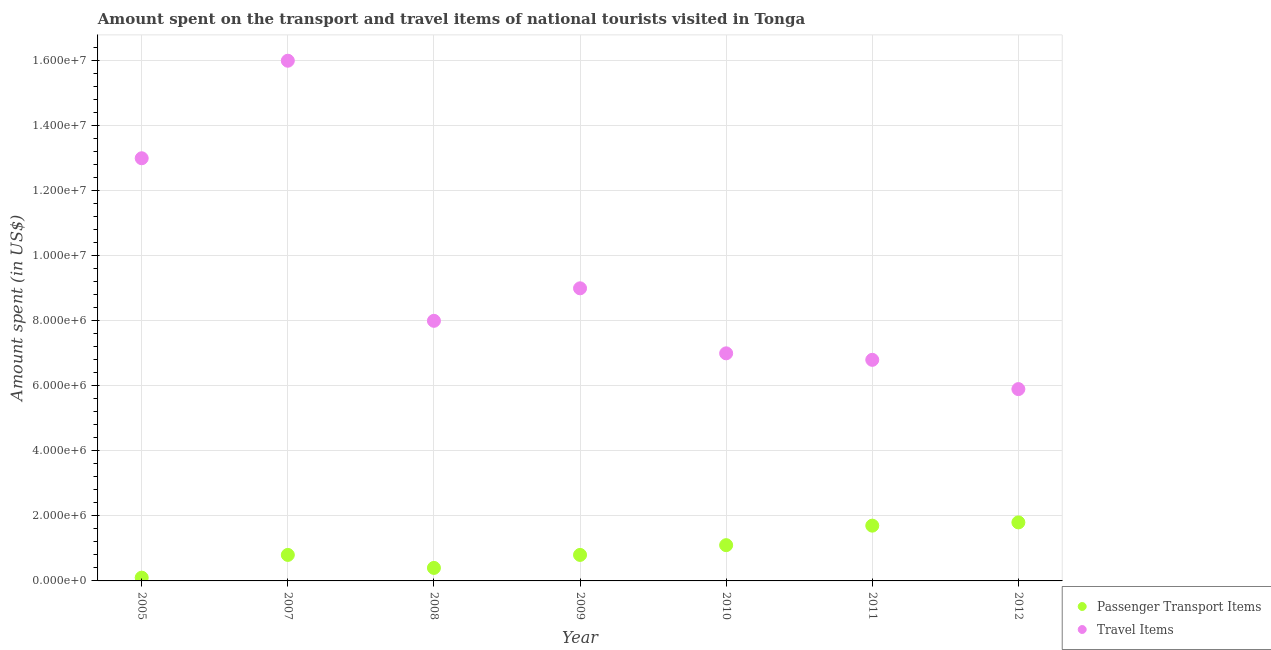How many different coloured dotlines are there?
Provide a short and direct response. 2. What is the amount spent on passenger transport items in 2012?
Your answer should be very brief. 1.80e+06. Across all years, what is the maximum amount spent on passenger transport items?
Your answer should be compact. 1.80e+06. Across all years, what is the minimum amount spent on passenger transport items?
Keep it short and to the point. 1.00e+05. In which year was the amount spent on passenger transport items maximum?
Keep it short and to the point. 2012. What is the total amount spent in travel items in the graph?
Offer a very short reply. 6.57e+07. What is the difference between the amount spent in travel items in 2010 and that in 2011?
Make the answer very short. 2.00e+05. What is the difference between the amount spent in travel items in 2011 and the amount spent on passenger transport items in 2010?
Offer a terse response. 5.70e+06. What is the average amount spent on passenger transport items per year?
Provide a succinct answer. 9.57e+05. In the year 2007, what is the difference between the amount spent in travel items and amount spent on passenger transport items?
Provide a short and direct response. 1.52e+07. In how many years, is the amount spent in travel items greater than 14800000 US$?
Offer a terse response. 1. What is the ratio of the amount spent on passenger transport items in 2009 to that in 2011?
Offer a terse response. 0.47. Is the difference between the amount spent in travel items in 2011 and 2012 greater than the difference between the amount spent on passenger transport items in 2011 and 2012?
Make the answer very short. Yes. What is the difference between the highest and the second highest amount spent in travel items?
Your answer should be compact. 3.00e+06. What is the difference between the highest and the lowest amount spent on passenger transport items?
Provide a short and direct response. 1.70e+06. In how many years, is the amount spent in travel items greater than the average amount spent in travel items taken over all years?
Offer a terse response. 2. How many years are there in the graph?
Provide a succinct answer. 7. What is the difference between two consecutive major ticks on the Y-axis?
Keep it short and to the point. 2.00e+06. Where does the legend appear in the graph?
Offer a terse response. Bottom right. How many legend labels are there?
Ensure brevity in your answer.  2. What is the title of the graph?
Your answer should be compact. Amount spent on the transport and travel items of national tourists visited in Tonga. Does "Researchers" appear as one of the legend labels in the graph?
Provide a succinct answer. No. What is the label or title of the X-axis?
Offer a very short reply. Year. What is the label or title of the Y-axis?
Provide a short and direct response. Amount spent (in US$). What is the Amount spent (in US$) of Passenger Transport Items in 2005?
Provide a succinct answer. 1.00e+05. What is the Amount spent (in US$) in Travel Items in 2005?
Your answer should be compact. 1.30e+07. What is the Amount spent (in US$) of Passenger Transport Items in 2007?
Offer a very short reply. 8.00e+05. What is the Amount spent (in US$) of Travel Items in 2007?
Make the answer very short. 1.60e+07. What is the Amount spent (in US$) of Travel Items in 2009?
Make the answer very short. 9.00e+06. What is the Amount spent (in US$) of Passenger Transport Items in 2010?
Provide a short and direct response. 1.10e+06. What is the Amount spent (in US$) of Passenger Transport Items in 2011?
Offer a very short reply. 1.70e+06. What is the Amount spent (in US$) of Travel Items in 2011?
Offer a terse response. 6.80e+06. What is the Amount spent (in US$) of Passenger Transport Items in 2012?
Offer a terse response. 1.80e+06. What is the Amount spent (in US$) in Travel Items in 2012?
Your answer should be very brief. 5.90e+06. Across all years, what is the maximum Amount spent (in US$) of Passenger Transport Items?
Ensure brevity in your answer.  1.80e+06. Across all years, what is the maximum Amount spent (in US$) of Travel Items?
Your answer should be very brief. 1.60e+07. Across all years, what is the minimum Amount spent (in US$) in Travel Items?
Provide a succinct answer. 5.90e+06. What is the total Amount spent (in US$) in Passenger Transport Items in the graph?
Provide a short and direct response. 6.70e+06. What is the total Amount spent (in US$) in Travel Items in the graph?
Your answer should be compact. 6.57e+07. What is the difference between the Amount spent (in US$) of Passenger Transport Items in 2005 and that in 2007?
Your response must be concise. -7.00e+05. What is the difference between the Amount spent (in US$) in Travel Items in 2005 and that in 2007?
Your answer should be very brief. -3.00e+06. What is the difference between the Amount spent (in US$) in Passenger Transport Items in 2005 and that in 2008?
Provide a succinct answer. -3.00e+05. What is the difference between the Amount spent (in US$) of Passenger Transport Items in 2005 and that in 2009?
Give a very brief answer. -7.00e+05. What is the difference between the Amount spent (in US$) of Travel Items in 2005 and that in 2009?
Ensure brevity in your answer.  4.00e+06. What is the difference between the Amount spent (in US$) of Passenger Transport Items in 2005 and that in 2010?
Give a very brief answer. -1.00e+06. What is the difference between the Amount spent (in US$) of Passenger Transport Items in 2005 and that in 2011?
Your answer should be very brief. -1.60e+06. What is the difference between the Amount spent (in US$) of Travel Items in 2005 and that in 2011?
Provide a short and direct response. 6.20e+06. What is the difference between the Amount spent (in US$) of Passenger Transport Items in 2005 and that in 2012?
Your answer should be compact. -1.70e+06. What is the difference between the Amount spent (in US$) in Travel Items in 2005 and that in 2012?
Ensure brevity in your answer.  7.10e+06. What is the difference between the Amount spent (in US$) of Passenger Transport Items in 2007 and that in 2008?
Your answer should be very brief. 4.00e+05. What is the difference between the Amount spent (in US$) in Travel Items in 2007 and that in 2009?
Give a very brief answer. 7.00e+06. What is the difference between the Amount spent (in US$) of Passenger Transport Items in 2007 and that in 2010?
Give a very brief answer. -3.00e+05. What is the difference between the Amount spent (in US$) of Travel Items in 2007 and that in 2010?
Ensure brevity in your answer.  9.00e+06. What is the difference between the Amount spent (in US$) of Passenger Transport Items in 2007 and that in 2011?
Make the answer very short. -9.00e+05. What is the difference between the Amount spent (in US$) in Travel Items in 2007 and that in 2011?
Offer a terse response. 9.20e+06. What is the difference between the Amount spent (in US$) in Passenger Transport Items in 2007 and that in 2012?
Your response must be concise. -1.00e+06. What is the difference between the Amount spent (in US$) in Travel Items in 2007 and that in 2012?
Your answer should be compact. 1.01e+07. What is the difference between the Amount spent (in US$) in Passenger Transport Items in 2008 and that in 2009?
Keep it short and to the point. -4.00e+05. What is the difference between the Amount spent (in US$) of Passenger Transport Items in 2008 and that in 2010?
Your answer should be very brief. -7.00e+05. What is the difference between the Amount spent (in US$) in Passenger Transport Items in 2008 and that in 2011?
Provide a short and direct response. -1.30e+06. What is the difference between the Amount spent (in US$) of Travel Items in 2008 and that in 2011?
Provide a succinct answer. 1.20e+06. What is the difference between the Amount spent (in US$) in Passenger Transport Items in 2008 and that in 2012?
Keep it short and to the point. -1.40e+06. What is the difference between the Amount spent (in US$) of Travel Items in 2008 and that in 2012?
Offer a very short reply. 2.10e+06. What is the difference between the Amount spent (in US$) in Passenger Transport Items in 2009 and that in 2010?
Your answer should be very brief. -3.00e+05. What is the difference between the Amount spent (in US$) in Travel Items in 2009 and that in 2010?
Make the answer very short. 2.00e+06. What is the difference between the Amount spent (in US$) of Passenger Transport Items in 2009 and that in 2011?
Offer a very short reply. -9.00e+05. What is the difference between the Amount spent (in US$) of Travel Items in 2009 and that in 2011?
Offer a very short reply. 2.20e+06. What is the difference between the Amount spent (in US$) of Travel Items in 2009 and that in 2012?
Ensure brevity in your answer.  3.10e+06. What is the difference between the Amount spent (in US$) in Passenger Transport Items in 2010 and that in 2011?
Provide a short and direct response. -6.00e+05. What is the difference between the Amount spent (in US$) of Travel Items in 2010 and that in 2011?
Offer a very short reply. 2.00e+05. What is the difference between the Amount spent (in US$) of Passenger Transport Items in 2010 and that in 2012?
Provide a succinct answer. -7.00e+05. What is the difference between the Amount spent (in US$) of Travel Items in 2010 and that in 2012?
Offer a terse response. 1.10e+06. What is the difference between the Amount spent (in US$) in Travel Items in 2011 and that in 2012?
Your answer should be compact. 9.00e+05. What is the difference between the Amount spent (in US$) in Passenger Transport Items in 2005 and the Amount spent (in US$) in Travel Items in 2007?
Your response must be concise. -1.59e+07. What is the difference between the Amount spent (in US$) of Passenger Transport Items in 2005 and the Amount spent (in US$) of Travel Items in 2008?
Make the answer very short. -7.90e+06. What is the difference between the Amount spent (in US$) of Passenger Transport Items in 2005 and the Amount spent (in US$) of Travel Items in 2009?
Your answer should be compact. -8.90e+06. What is the difference between the Amount spent (in US$) in Passenger Transport Items in 2005 and the Amount spent (in US$) in Travel Items in 2010?
Make the answer very short. -6.90e+06. What is the difference between the Amount spent (in US$) in Passenger Transport Items in 2005 and the Amount spent (in US$) in Travel Items in 2011?
Offer a very short reply. -6.70e+06. What is the difference between the Amount spent (in US$) of Passenger Transport Items in 2005 and the Amount spent (in US$) of Travel Items in 2012?
Your answer should be compact. -5.80e+06. What is the difference between the Amount spent (in US$) in Passenger Transport Items in 2007 and the Amount spent (in US$) in Travel Items in 2008?
Keep it short and to the point. -7.20e+06. What is the difference between the Amount spent (in US$) of Passenger Transport Items in 2007 and the Amount spent (in US$) of Travel Items in 2009?
Your answer should be very brief. -8.20e+06. What is the difference between the Amount spent (in US$) of Passenger Transport Items in 2007 and the Amount spent (in US$) of Travel Items in 2010?
Your response must be concise. -6.20e+06. What is the difference between the Amount spent (in US$) of Passenger Transport Items in 2007 and the Amount spent (in US$) of Travel Items in 2011?
Offer a terse response. -6.00e+06. What is the difference between the Amount spent (in US$) in Passenger Transport Items in 2007 and the Amount spent (in US$) in Travel Items in 2012?
Offer a terse response. -5.10e+06. What is the difference between the Amount spent (in US$) of Passenger Transport Items in 2008 and the Amount spent (in US$) of Travel Items in 2009?
Offer a terse response. -8.60e+06. What is the difference between the Amount spent (in US$) in Passenger Transport Items in 2008 and the Amount spent (in US$) in Travel Items in 2010?
Make the answer very short. -6.60e+06. What is the difference between the Amount spent (in US$) of Passenger Transport Items in 2008 and the Amount spent (in US$) of Travel Items in 2011?
Keep it short and to the point. -6.40e+06. What is the difference between the Amount spent (in US$) of Passenger Transport Items in 2008 and the Amount spent (in US$) of Travel Items in 2012?
Your answer should be compact. -5.50e+06. What is the difference between the Amount spent (in US$) in Passenger Transport Items in 2009 and the Amount spent (in US$) in Travel Items in 2010?
Give a very brief answer. -6.20e+06. What is the difference between the Amount spent (in US$) in Passenger Transport Items in 2009 and the Amount spent (in US$) in Travel Items in 2011?
Your answer should be compact. -6.00e+06. What is the difference between the Amount spent (in US$) of Passenger Transport Items in 2009 and the Amount spent (in US$) of Travel Items in 2012?
Give a very brief answer. -5.10e+06. What is the difference between the Amount spent (in US$) of Passenger Transport Items in 2010 and the Amount spent (in US$) of Travel Items in 2011?
Provide a succinct answer. -5.70e+06. What is the difference between the Amount spent (in US$) of Passenger Transport Items in 2010 and the Amount spent (in US$) of Travel Items in 2012?
Provide a succinct answer. -4.80e+06. What is the difference between the Amount spent (in US$) of Passenger Transport Items in 2011 and the Amount spent (in US$) of Travel Items in 2012?
Your response must be concise. -4.20e+06. What is the average Amount spent (in US$) of Passenger Transport Items per year?
Keep it short and to the point. 9.57e+05. What is the average Amount spent (in US$) of Travel Items per year?
Offer a terse response. 9.39e+06. In the year 2005, what is the difference between the Amount spent (in US$) in Passenger Transport Items and Amount spent (in US$) in Travel Items?
Offer a very short reply. -1.29e+07. In the year 2007, what is the difference between the Amount spent (in US$) of Passenger Transport Items and Amount spent (in US$) of Travel Items?
Your answer should be compact. -1.52e+07. In the year 2008, what is the difference between the Amount spent (in US$) in Passenger Transport Items and Amount spent (in US$) in Travel Items?
Your answer should be compact. -7.60e+06. In the year 2009, what is the difference between the Amount spent (in US$) in Passenger Transport Items and Amount spent (in US$) in Travel Items?
Your response must be concise. -8.20e+06. In the year 2010, what is the difference between the Amount spent (in US$) in Passenger Transport Items and Amount spent (in US$) in Travel Items?
Your answer should be compact. -5.90e+06. In the year 2011, what is the difference between the Amount spent (in US$) in Passenger Transport Items and Amount spent (in US$) in Travel Items?
Provide a short and direct response. -5.10e+06. In the year 2012, what is the difference between the Amount spent (in US$) of Passenger Transport Items and Amount spent (in US$) of Travel Items?
Your response must be concise. -4.10e+06. What is the ratio of the Amount spent (in US$) in Passenger Transport Items in 2005 to that in 2007?
Provide a short and direct response. 0.12. What is the ratio of the Amount spent (in US$) of Travel Items in 2005 to that in 2007?
Your response must be concise. 0.81. What is the ratio of the Amount spent (in US$) of Passenger Transport Items in 2005 to that in 2008?
Make the answer very short. 0.25. What is the ratio of the Amount spent (in US$) of Travel Items in 2005 to that in 2008?
Ensure brevity in your answer.  1.62. What is the ratio of the Amount spent (in US$) of Travel Items in 2005 to that in 2009?
Your response must be concise. 1.44. What is the ratio of the Amount spent (in US$) of Passenger Transport Items in 2005 to that in 2010?
Your answer should be compact. 0.09. What is the ratio of the Amount spent (in US$) in Travel Items in 2005 to that in 2010?
Your response must be concise. 1.86. What is the ratio of the Amount spent (in US$) in Passenger Transport Items in 2005 to that in 2011?
Provide a short and direct response. 0.06. What is the ratio of the Amount spent (in US$) of Travel Items in 2005 to that in 2011?
Your answer should be compact. 1.91. What is the ratio of the Amount spent (in US$) of Passenger Transport Items in 2005 to that in 2012?
Give a very brief answer. 0.06. What is the ratio of the Amount spent (in US$) in Travel Items in 2005 to that in 2012?
Ensure brevity in your answer.  2.2. What is the ratio of the Amount spent (in US$) in Travel Items in 2007 to that in 2008?
Provide a short and direct response. 2. What is the ratio of the Amount spent (in US$) of Travel Items in 2007 to that in 2009?
Ensure brevity in your answer.  1.78. What is the ratio of the Amount spent (in US$) in Passenger Transport Items in 2007 to that in 2010?
Give a very brief answer. 0.73. What is the ratio of the Amount spent (in US$) in Travel Items in 2007 to that in 2010?
Provide a succinct answer. 2.29. What is the ratio of the Amount spent (in US$) in Passenger Transport Items in 2007 to that in 2011?
Ensure brevity in your answer.  0.47. What is the ratio of the Amount spent (in US$) of Travel Items in 2007 to that in 2011?
Provide a short and direct response. 2.35. What is the ratio of the Amount spent (in US$) in Passenger Transport Items in 2007 to that in 2012?
Offer a very short reply. 0.44. What is the ratio of the Amount spent (in US$) in Travel Items in 2007 to that in 2012?
Give a very brief answer. 2.71. What is the ratio of the Amount spent (in US$) of Passenger Transport Items in 2008 to that in 2009?
Offer a terse response. 0.5. What is the ratio of the Amount spent (in US$) of Passenger Transport Items in 2008 to that in 2010?
Make the answer very short. 0.36. What is the ratio of the Amount spent (in US$) of Passenger Transport Items in 2008 to that in 2011?
Ensure brevity in your answer.  0.24. What is the ratio of the Amount spent (in US$) of Travel Items in 2008 to that in 2011?
Keep it short and to the point. 1.18. What is the ratio of the Amount spent (in US$) of Passenger Transport Items in 2008 to that in 2012?
Ensure brevity in your answer.  0.22. What is the ratio of the Amount spent (in US$) in Travel Items in 2008 to that in 2012?
Keep it short and to the point. 1.36. What is the ratio of the Amount spent (in US$) of Passenger Transport Items in 2009 to that in 2010?
Your answer should be compact. 0.73. What is the ratio of the Amount spent (in US$) in Passenger Transport Items in 2009 to that in 2011?
Your answer should be very brief. 0.47. What is the ratio of the Amount spent (in US$) of Travel Items in 2009 to that in 2011?
Your answer should be very brief. 1.32. What is the ratio of the Amount spent (in US$) in Passenger Transport Items in 2009 to that in 2012?
Give a very brief answer. 0.44. What is the ratio of the Amount spent (in US$) of Travel Items in 2009 to that in 2012?
Offer a very short reply. 1.53. What is the ratio of the Amount spent (in US$) of Passenger Transport Items in 2010 to that in 2011?
Your answer should be very brief. 0.65. What is the ratio of the Amount spent (in US$) of Travel Items in 2010 to that in 2011?
Offer a very short reply. 1.03. What is the ratio of the Amount spent (in US$) in Passenger Transport Items in 2010 to that in 2012?
Offer a very short reply. 0.61. What is the ratio of the Amount spent (in US$) in Travel Items in 2010 to that in 2012?
Ensure brevity in your answer.  1.19. What is the ratio of the Amount spent (in US$) in Passenger Transport Items in 2011 to that in 2012?
Offer a very short reply. 0.94. What is the ratio of the Amount spent (in US$) in Travel Items in 2011 to that in 2012?
Your answer should be compact. 1.15. What is the difference between the highest and the second highest Amount spent (in US$) in Passenger Transport Items?
Offer a terse response. 1.00e+05. What is the difference between the highest and the second highest Amount spent (in US$) of Travel Items?
Give a very brief answer. 3.00e+06. What is the difference between the highest and the lowest Amount spent (in US$) of Passenger Transport Items?
Your response must be concise. 1.70e+06. What is the difference between the highest and the lowest Amount spent (in US$) of Travel Items?
Your answer should be very brief. 1.01e+07. 